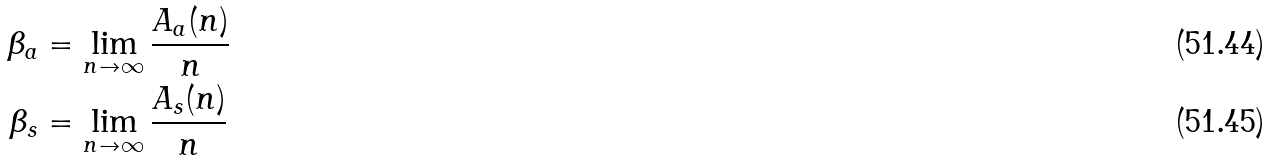<formula> <loc_0><loc_0><loc_500><loc_500>\beta _ { a } & = \lim _ { n \to \infty } \frac { A _ { a } ( n ) } { n } \\ \beta _ { s } & = \lim _ { n \to \infty } \frac { A _ { s } ( n ) } { n }</formula> 